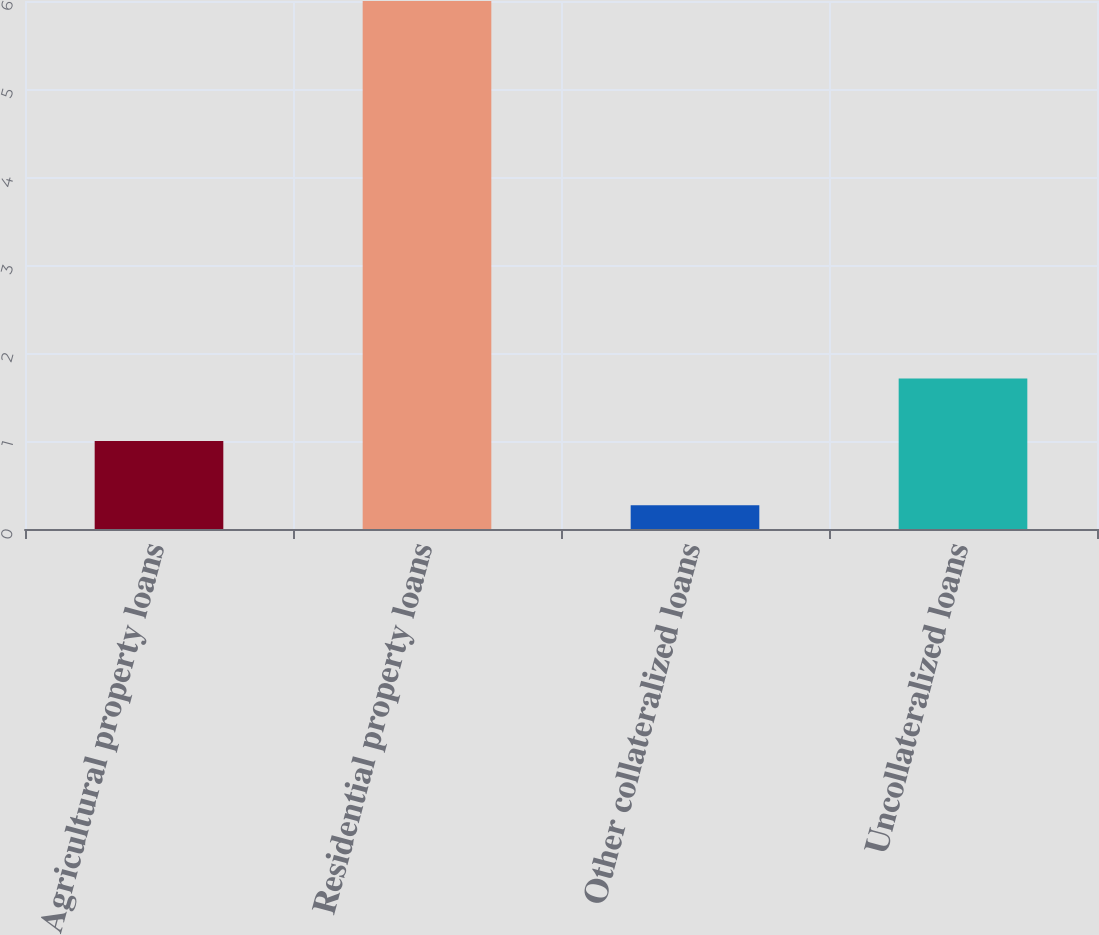<chart> <loc_0><loc_0><loc_500><loc_500><bar_chart><fcel>Agricultural property loans<fcel>Residential property loans<fcel>Other collateralized loans<fcel>Uncollateralized loans<nl><fcel>1<fcel>6<fcel>0.27<fcel>1.71<nl></chart> 